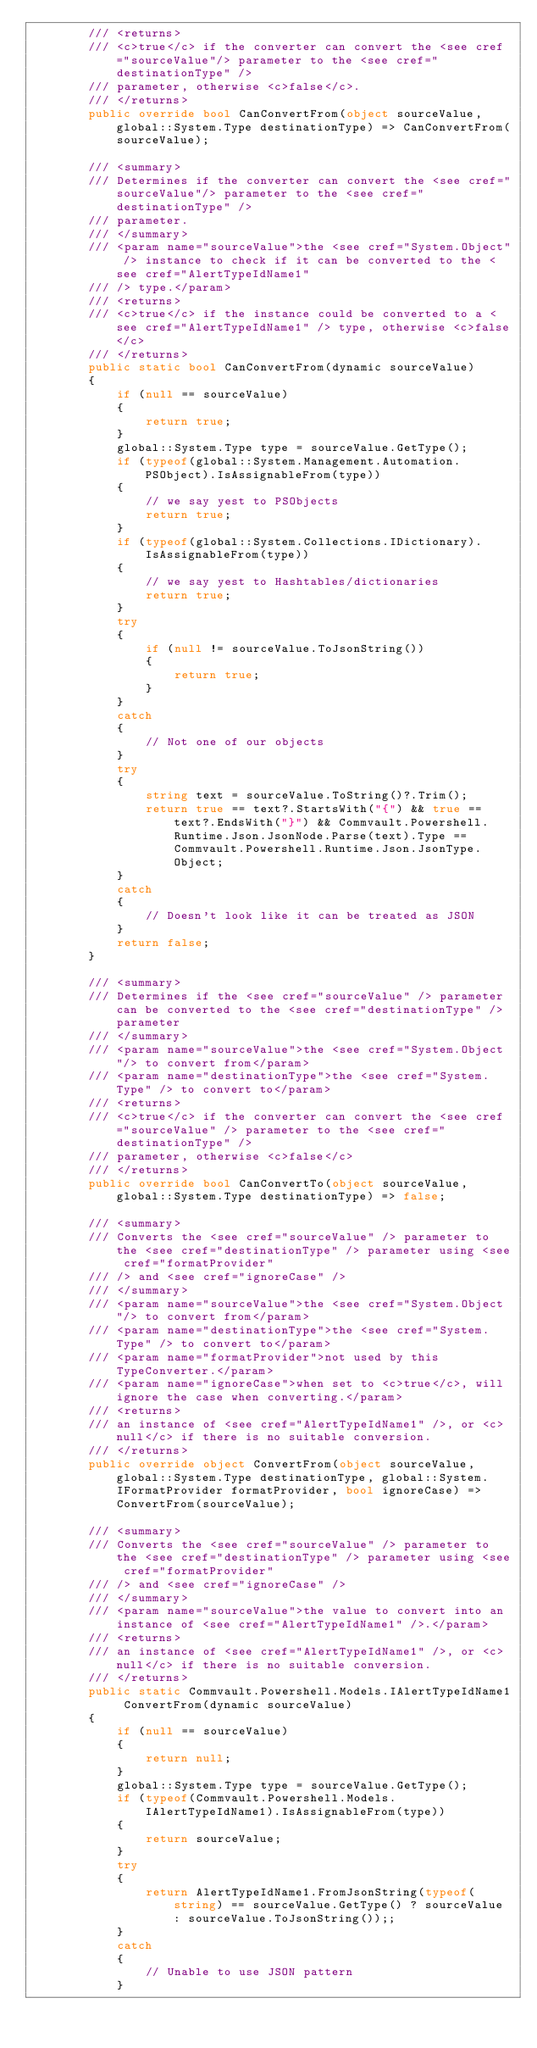<code> <loc_0><loc_0><loc_500><loc_500><_C#_>        /// <returns>
        /// <c>true</c> if the converter can convert the <see cref="sourceValue"/> parameter to the <see cref="destinationType" />
        /// parameter, otherwise <c>false</c>.
        /// </returns>
        public override bool CanConvertFrom(object sourceValue, global::System.Type destinationType) => CanConvertFrom(sourceValue);

        /// <summary>
        /// Determines if the converter can convert the <see cref="sourceValue"/> parameter to the <see cref="destinationType" />
        /// parameter.
        /// </summary>
        /// <param name="sourceValue">the <see cref="System.Object" /> instance to check if it can be converted to the <see cref="AlertTypeIdName1"
        /// /> type.</param>
        /// <returns>
        /// <c>true</c> if the instance could be converted to a <see cref="AlertTypeIdName1" /> type, otherwise <c>false</c>
        /// </returns>
        public static bool CanConvertFrom(dynamic sourceValue)
        {
            if (null == sourceValue)
            {
                return true;
            }
            global::System.Type type = sourceValue.GetType();
            if (typeof(global::System.Management.Automation.PSObject).IsAssignableFrom(type))
            {
                // we say yest to PSObjects
                return true;
            }
            if (typeof(global::System.Collections.IDictionary).IsAssignableFrom(type))
            {
                // we say yest to Hashtables/dictionaries
                return true;
            }
            try
            {
                if (null != sourceValue.ToJsonString())
                {
                    return true;
                }
            }
            catch
            {
                // Not one of our objects
            }
            try
            {
                string text = sourceValue.ToString()?.Trim();
                return true == text?.StartsWith("{") && true == text?.EndsWith("}") && Commvault.Powershell.Runtime.Json.JsonNode.Parse(text).Type == Commvault.Powershell.Runtime.Json.JsonType.Object;
            }
            catch
            {
                // Doesn't look like it can be treated as JSON
            }
            return false;
        }

        /// <summary>
        /// Determines if the <see cref="sourceValue" /> parameter can be converted to the <see cref="destinationType" /> parameter
        /// </summary>
        /// <param name="sourceValue">the <see cref="System.Object"/> to convert from</param>
        /// <param name="destinationType">the <see cref="System.Type" /> to convert to</param>
        /// <returns>
        /// <c>true</c> if the converter can convert the <see cref="sourceValue" /> parameter to the <see cref="destinationType" />
        /// parameter, otherwise <c>false</c>
        /// </returns>
        public override bool CanConvertTo(object sourceValue, global::System.Type destinationType) => false;

        /// <summary>
        /// Converts the <see cref="sourceValue" /> parameter to the <see cref="destinationType" /> parameter using <see cref="formatProvider"
        /// /> and <see cref="ignoreCase" />
        /// </summary>
        /// <param name="sourceValue">the <see cref="System.Object"/> to convert from</param>
        /// <param name="destinationType">the <see cref="System.Type" /> to convert to</param>
        /// <param name="formatProvider">not used by this TypeConverter.</param>
        /// <param name="ignoreCase">when set to <c>true</c>, will ignore the case when converting.</param>
        /// <returns>
        /// an instance of <see cref="AlertTypeIdName1" />, or <c>null</c> if there is no suitable conversion.
        /// </returns>
        public override object ConvertFrom(object sourceValue, global::System.Type destinationType, global::System.IFormatProvider formatProvider, bool ignoreCase) => ConvertFrom(sourceValue);

        /// <summary>
        /// Converts the <see cref="sourceValue" /> parameter to the <see cref="destinationType" /> parameter using <see cref="formatProvider"
        /// /> and <see cref="ignoreCase" />
        /// </summary>
        /// <param name="sourceValue">the value to convert into an instance of <see cref="AlertTypeIdName1" />.</param>
        /// <returns>
        /// an instance of <see cref="AlertTypeIdName1" />, or <c>null</c> if there is no suitable conversion.
        /// </returns>
        public static Commvault.Powershell.Models.IAlertTypeIdName1 ConvertFrom(dynamic sourceValue)
        {
            if (null == sourceValue)
            {
                return null;
            }
            global::System.Type type = sourceValue.GetType();
            if (typeof(Commvault.Powershell.Models.IAlertTypeIdName1).IsAssignableFrom(type))
            {
                return sourceValue;
            }
            try
            {
                return AlertTypeIdName1.FromJsonString(typeof(string) == sourceValue.GetType() ? sourceValue : sourceValue.ToJsonString());;
            }
            catch
            {
                // Unable to use JSON pattern
            }</code> 